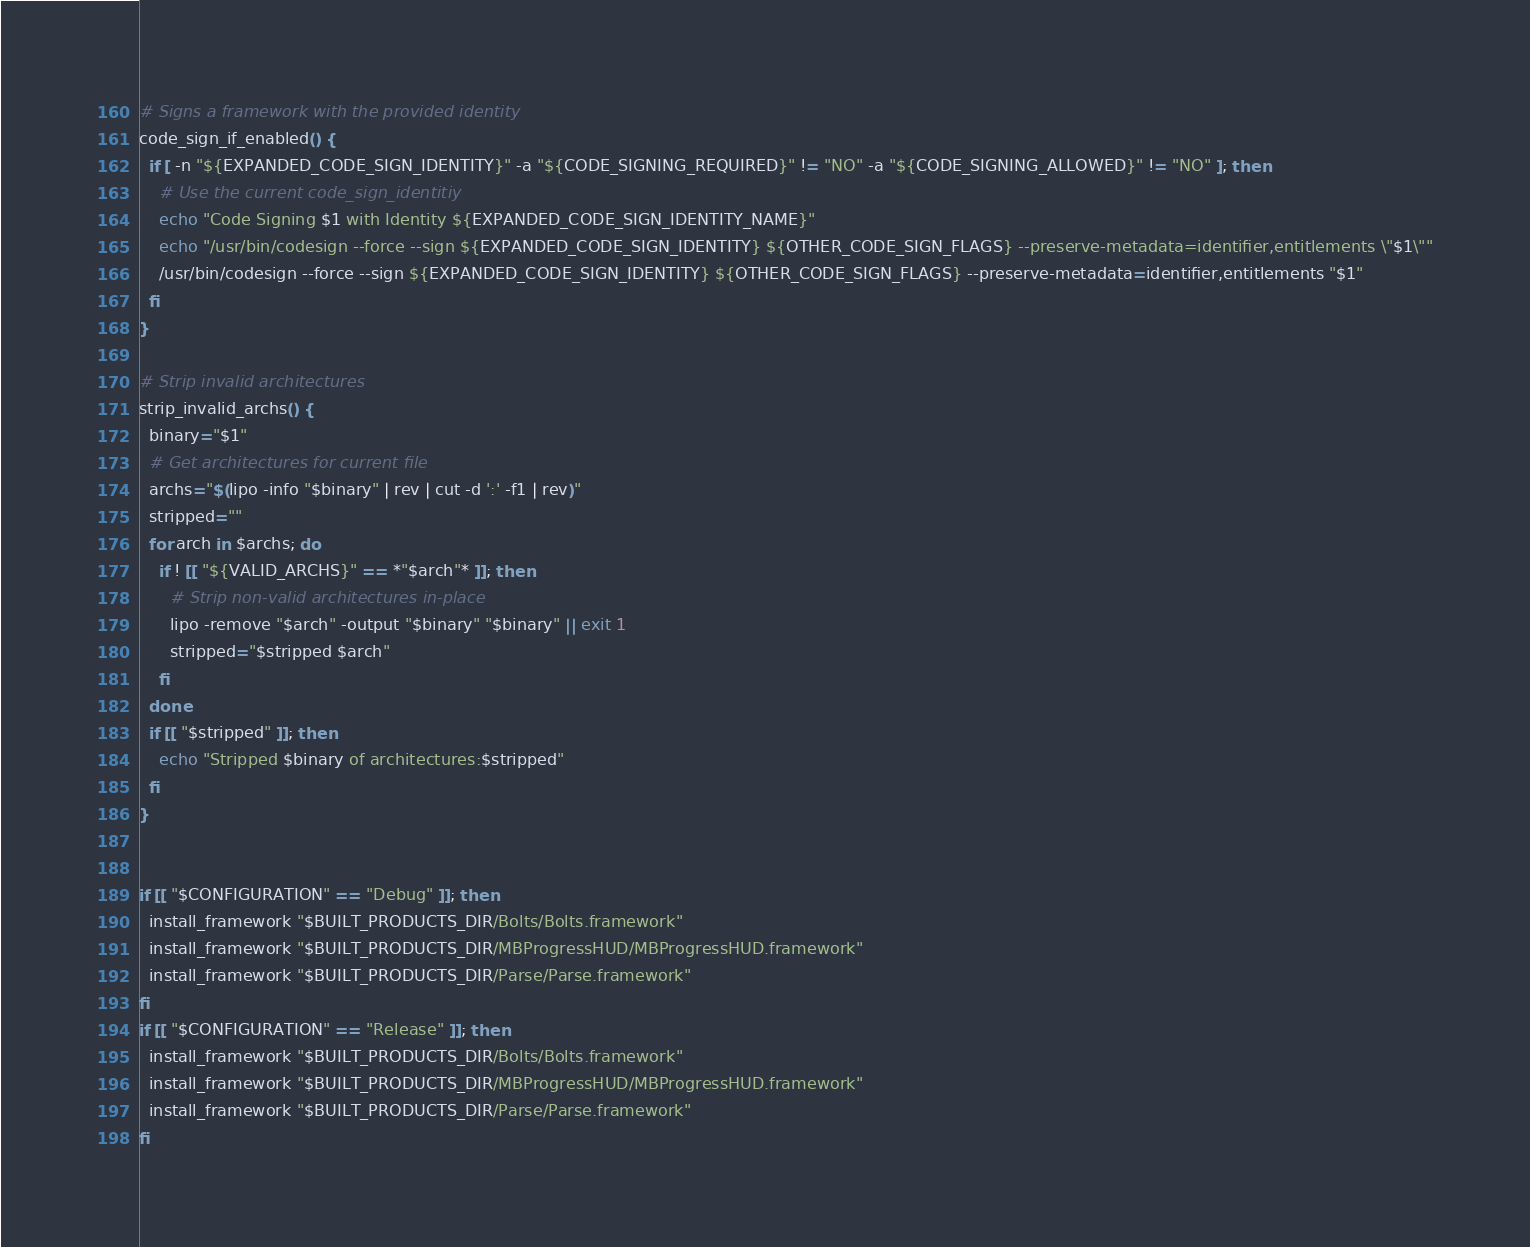<code> <loc_0><loc_0><loc_500><loc_500><_Bash_># Signs a framework with the provided identity
code_sign_if_enabled() {
  if [ -n "${EXPANDED_CODE_SIGN_IDENTITY}" -a "${CODE_SIGNING_REQUIRED}" != "NO" -a "${CODE_SIGNING_ALLOWED}" != "NO" ]; then
    # Use the current code_sign_identitiy
    echo "Code Signing $1 with Identity ${EXPANDED_CODE_SIGN_IDENTITY_NAME}"
    echo "/usr/bin/codesign --force --sign ${EXPANDED_CODE_SIGN_IDENTITY} ${OTHER_CODE_SIGN_FLAGS} --preserve-metadata=identifier,entitlements \"$1\""
    /usr/bin/codesign --force --sign ${EXPANDED_CODE_SIGN_IDENTITY} ${OTHER_CODE_SIGN_FLAGS} --preserve-metadata=identifier,entitlements "$1"
  fi
}

# Strip invalid architectures
strip_invalid_archs() {
  binary="$1"
  # Get architectures for current file
  archs="$(lipo -info "$binary" | rev | cut -d ':' -f1 | rev)"
  stripped=""
  for arch in $archs; do
    if ! [[ "${VALID_ARCHS}" == *"$arch"* ]]; then
      # Strip non-valid architectures in-place
      lipo -remove "$arch" -output "$binary" "$binary" || exit 1
      stripped="$stripped $arch"
    fi
  done
  if [[ "$stripped" ]]; then
    echo "Stripped $binary of architectures:$stripped"
  fi
}


if [[ "$CONFIGURATION" == "Debug" ]]; then
  install_framework "$BUILT_PRODUCTS_DIR/Bolts/Bolts.framework"
  install_framework "$BUILT_PRODUCTS_DIR/MBProgressHUD/MBProgressHUD.framework"
  install_framework "$BUILT_PRODUCTS_DIR/Parse/Parse.framework"
fi
if [[ "$CONFIGURATION" == "Release" ]]; then
  install_framework "$BUILT_PRODUCTS_DIR/Bolts/Bolts.framework"
  install_framework "$BUILT_PRODUCTS_DIR/MBProgressHUD/MBProgressHUD.framework"
  install_framework "$BUILT_PRODUCTS_DIR/Parse/Parse.framework"
fi
</code> 